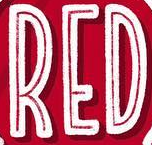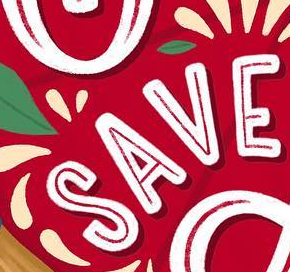What words are shown in these images in order, separated by a semicolon? RED; SAVE 